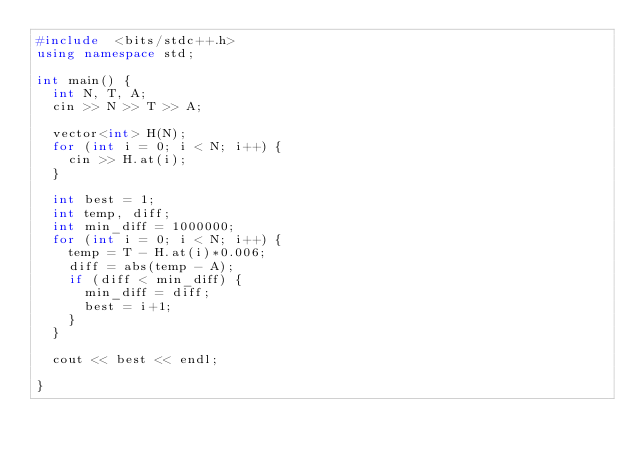<code> <loc_0><loc_0><loc_500><loc_500><_C++_>#include  <bits/stdc++.h>
using namespace std;

int main() {
  int N, T, A;
  cin >> N >> T >> A;
  
  vector<int> H(N);
  for (int i = 0; i < N; i++) {
    cin >> H.at(i);
  }
  
  int best = 1;
  int temp, diff;
  int min_diff = 1000000;
  for (int i = 0; i < N; i++) {
    temp = T - H.at(i)*0.006;
    diff = abs(temp - A);
    if (diff < min_diff) {
      min_diff = diff;
      best = i+1;
    }
  }
  
  cout << best << endl;
  
}
</code> 